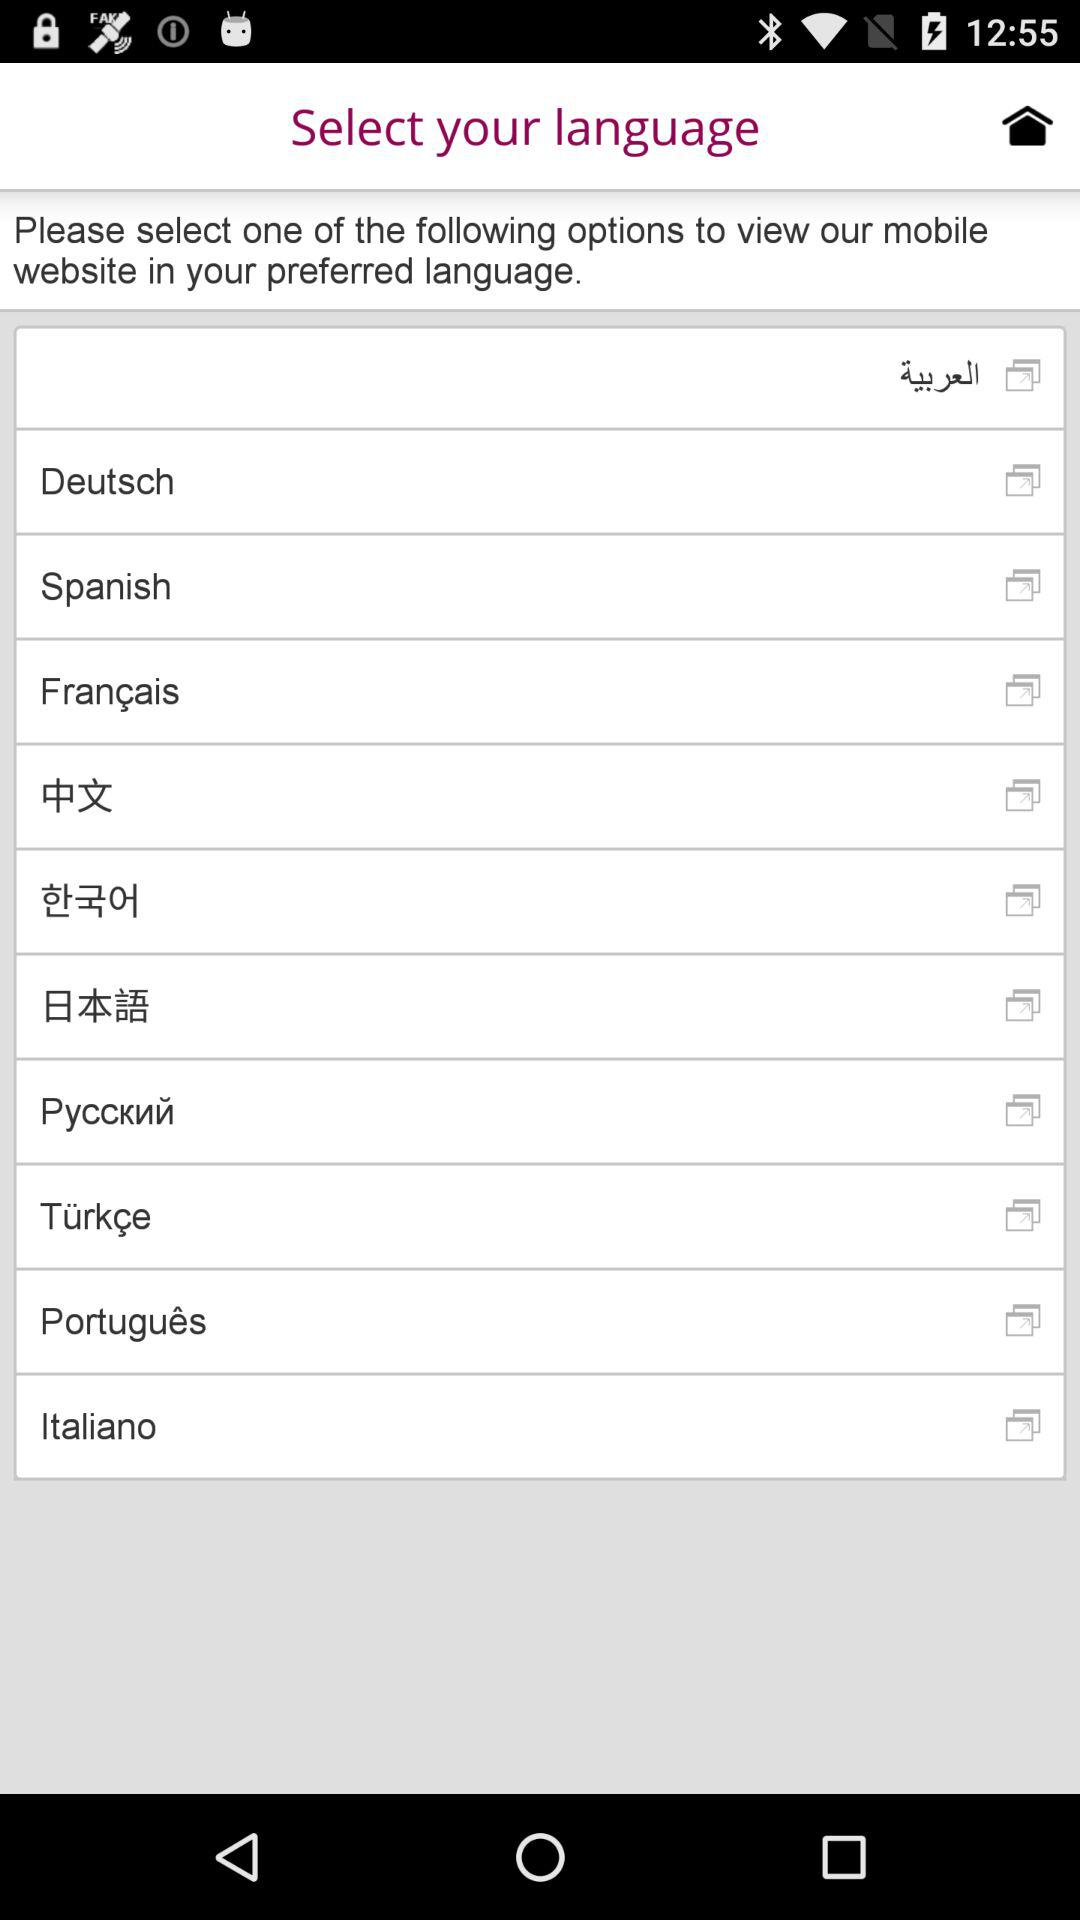How many languages are available for selection on this screen?
Answer the question using a single word or phrase. 10 